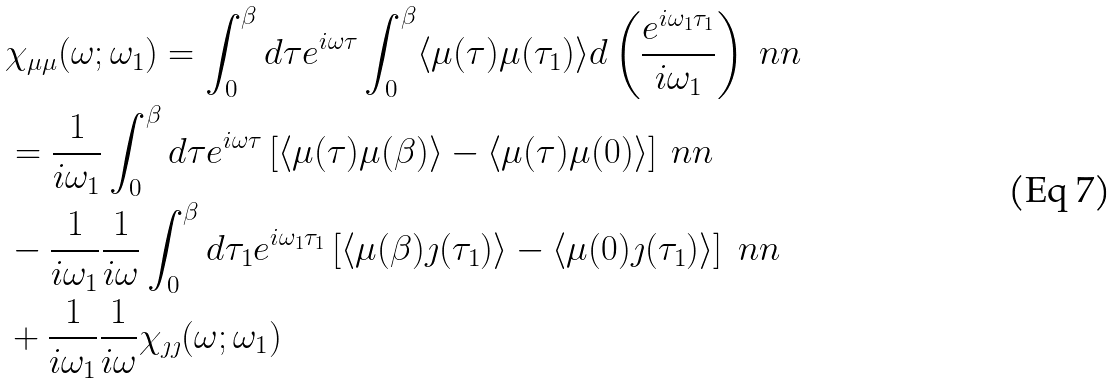<formula> <loc_0><loc_0><loc_500><loc_500>& \chi _ { \mu \mu } ( \omega ; \omega _ { 1 } ) = \int _ { 0 } ^ { \beta } d \tau e ^ { i \omega \tau } \int _ { 0 } ^ { \beta } \langle \mu ( \tau ) \mu ( \tau _ { 1 } ) \rangle d \left ( \frac { e ^ { i \omega _ { 1 } \tau _ { 1 } } } { i \omega _ { 1 } } \right ) \ n n \\ & = \frac { 1 } { i \omega _ { 1 } } \int _ { 0 } ^ { \beta } d \tau e ^ { i \omega \tau } \left [ \langle \mu ( \tau ) \mu ( \beta ) \rangle - \langle \mu ( \tau ) \mu ( 0 ) \rangle \right ] \ n n \\ & - \frac { 1 } { i \omega _ { 1 } } \frac { 1 } { i \omega } \int _ { 0 } ^ { \beta } d \tau _ { 1 } e ^ { i \omega _ { 1 } \tau _ { 1 } } \left [ \langle \mu ( \beta ) \jmath ( \tau _ { 1 } ) \rangle - \langle \mu ( 0 ) \jmath ( \tau _ { 1 } ) \rangle \right ] \ n n \\ & + \frac { 1 } { i \omega _ { 1 } } \frac { 1 } { i \omega } \chi _ { \jmath \jmath } ( \omega ; \omega _ { 1 } )</formula> 